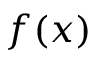<formula> <loc_0><loc_0><loc_500><loc_500>f ( x )</formula> 